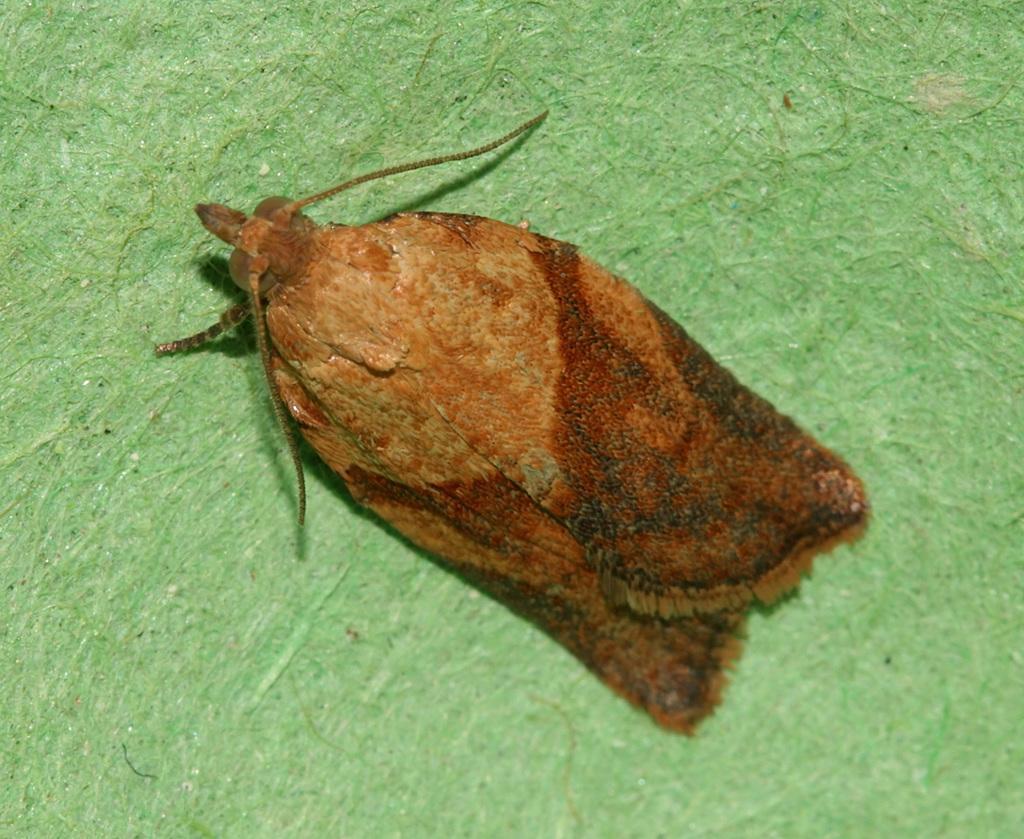Please provide a concise description of this image. In this picture I can see an insect which is of brown in color and it is on the green color surface. 